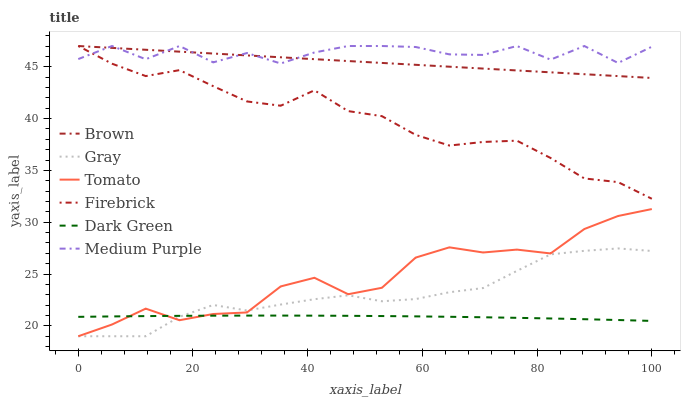Does Dark Green have the minimum area under the curve?
Answer yes or no. Yes. Does Medium Purple have the maximum area under the curve?
Answer yes or no. Yes. Does Brown have the minimum area under the curve?
Answer yes or no. No. Does Brown have the maximum area under the curve?
Answer yes or no. No. Is Brown the smoothest?
Answer yes or no. Yes. Is Medium Purple the roughest?
Answer yes or no. Yes. Is Gray the smoothest?
Answer yes or no. No. Is Gray the roughest?
Answer yes or no. No. Does Brown have the lowest value?
Answer yes or no. No. Does Gray have the highest value?
Answer yes or no. No. Is Tomato less than Medium Purple?
Answer yes or no. Yes. Is Medium Purple greater than Tomato?
Answer yes or no. Yes. Does Tomato intersect Medium Purple?
Answer yes or no. No. 